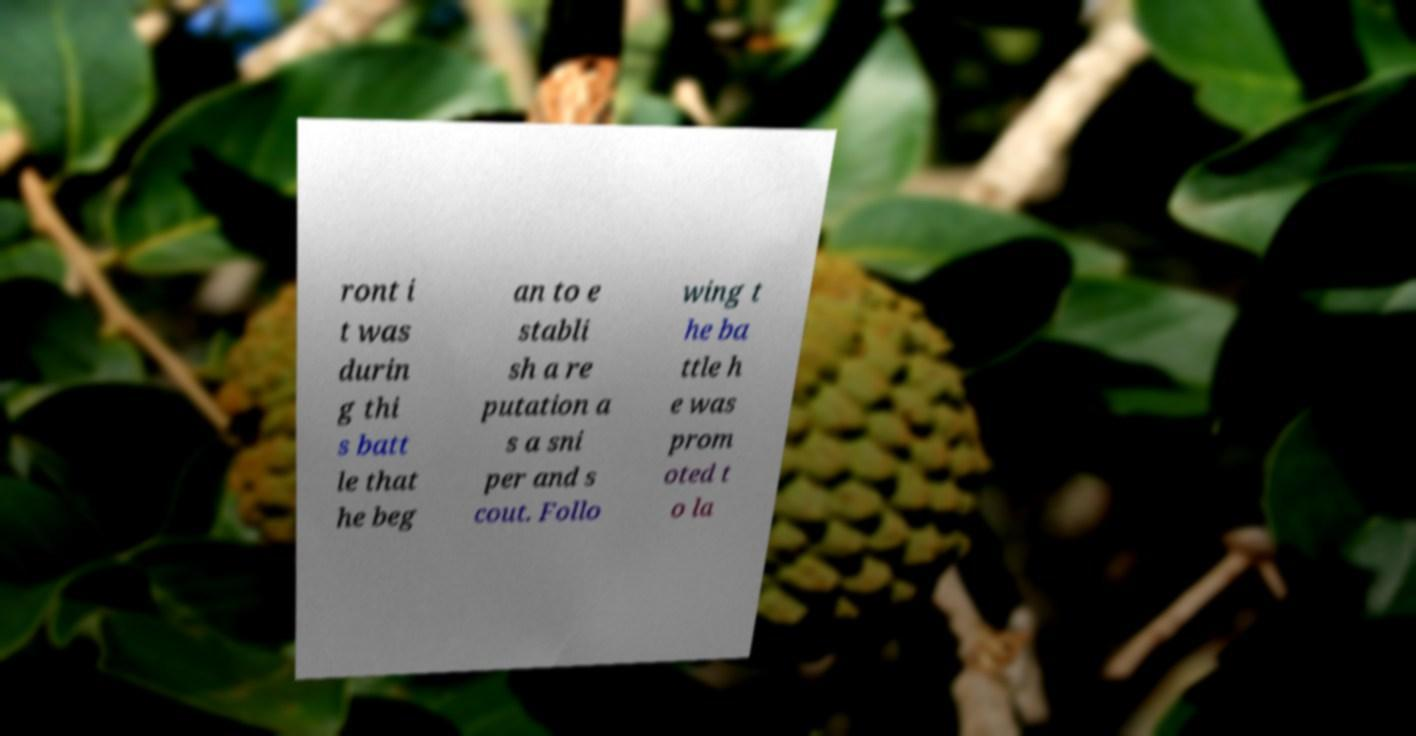Please read and relay the text visible in this image. What does it say? ront i t was durin g thi s batt le that he beg an to e stabli sh a re putation a s a sni per and s cout. Follo wing t he ba ttle h e was prom oted t o la 